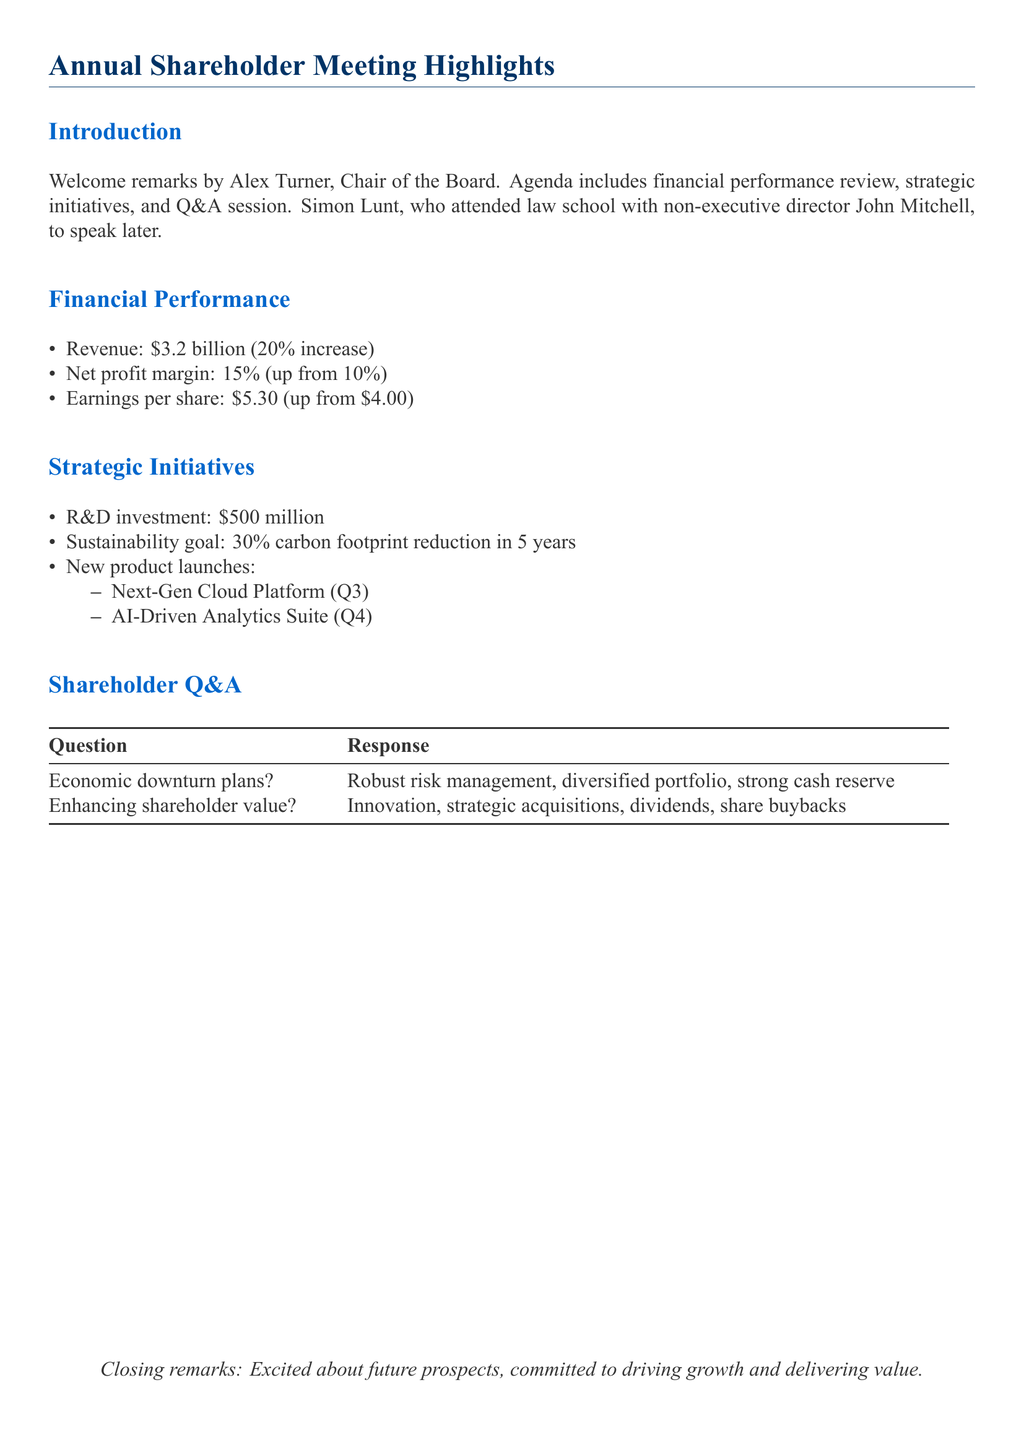What was the revenue for the year? The document states that the revenue is $3.2 billion.
Answer: $3.2 billion What is the net profit margin percentage? The net profit margin is indicated as 15%.
Answer: 15% What is the earnings per share figure? It is mentioned that earnings per share are $5.30.
Answer: $5.30 How much is being invested in R&D? The document specifies an R&D investment of $500 million.
Answer: $500 million What is the sustainability goal mentioned? A 30% carbon footprint reduction in 5 years is noted as the sustainability goal.
Answer: 30% carbon footprint reduction in 5 years What product is launching in Q3? The Next-Gen Cloud Platform is stated to launch in Q3.
Answer: Next-Gen Cloud Platform What is the key strategy for enhancing shareholder value? Innovation, strategic acquisitions, dividends, and share buybacks are cited as strategies to enhance shareholder value.
Answer: Innovation, strategic acquisitions, dividends, share buybacks What type of risk management does the company plan to implement? The company plans to implement robust risk management strategies.
Answer: Robust risk management Who delivered the welcome remarks at the meeting? Alex Turner, Chair of the Board, delivered the welcome remarks.
Answer: Alex Turner 